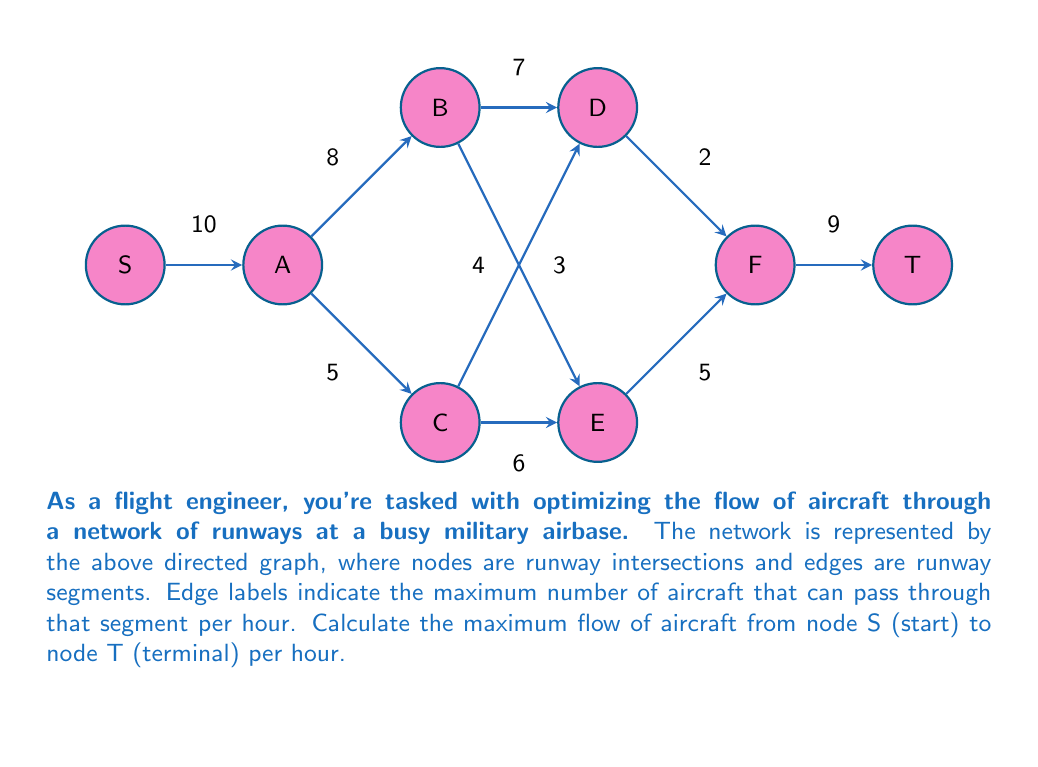Teach me how to tackle this problem. To solve this maximum flow problem, we'll use the Ford-Fulkerson algorithm:

1) Initialize flow to 0 for all edges.

2) While there exists an augmenting path from S to T:
   a) Find an augmenting path
   b) Determine the bottleneck capacity
   c) Update the flow along the path

3) Repeat step 2 until no augmenting path exists

Let's apply this algorithm:

Iteration 1:
Path: S -> A -> B -> D -> F -> T
Bottleneck: min(10, 8, 7, 2, 9) = 2
Flow: 2

Iteration 2:
Path: S -> A -> C -> E -> F -> T
Bottleneck: min(10-2, 5, 6, 5, 9-2) = 5
Flow: 2 + 5 = 7

Iteration 3:
Path: S -> A -> B -> E -> F -> T
Bottleneck: min(10-7, 8-2, 3, 5-5, 9-7) = 1
Flow: 7 + 1 = 8

Iteration 4:
Path: S -> A -> C -> D -> F -> T
Bottleneck: min(10-8, 5-5, 4, 2-2, 9-8) = 0

No more augmenting paths exist, so the algorithm terminates.

The maximum flow is the sum of all flows entering T, which is 8 aircraft per hour.
Answer: 8 aircraft per hour 